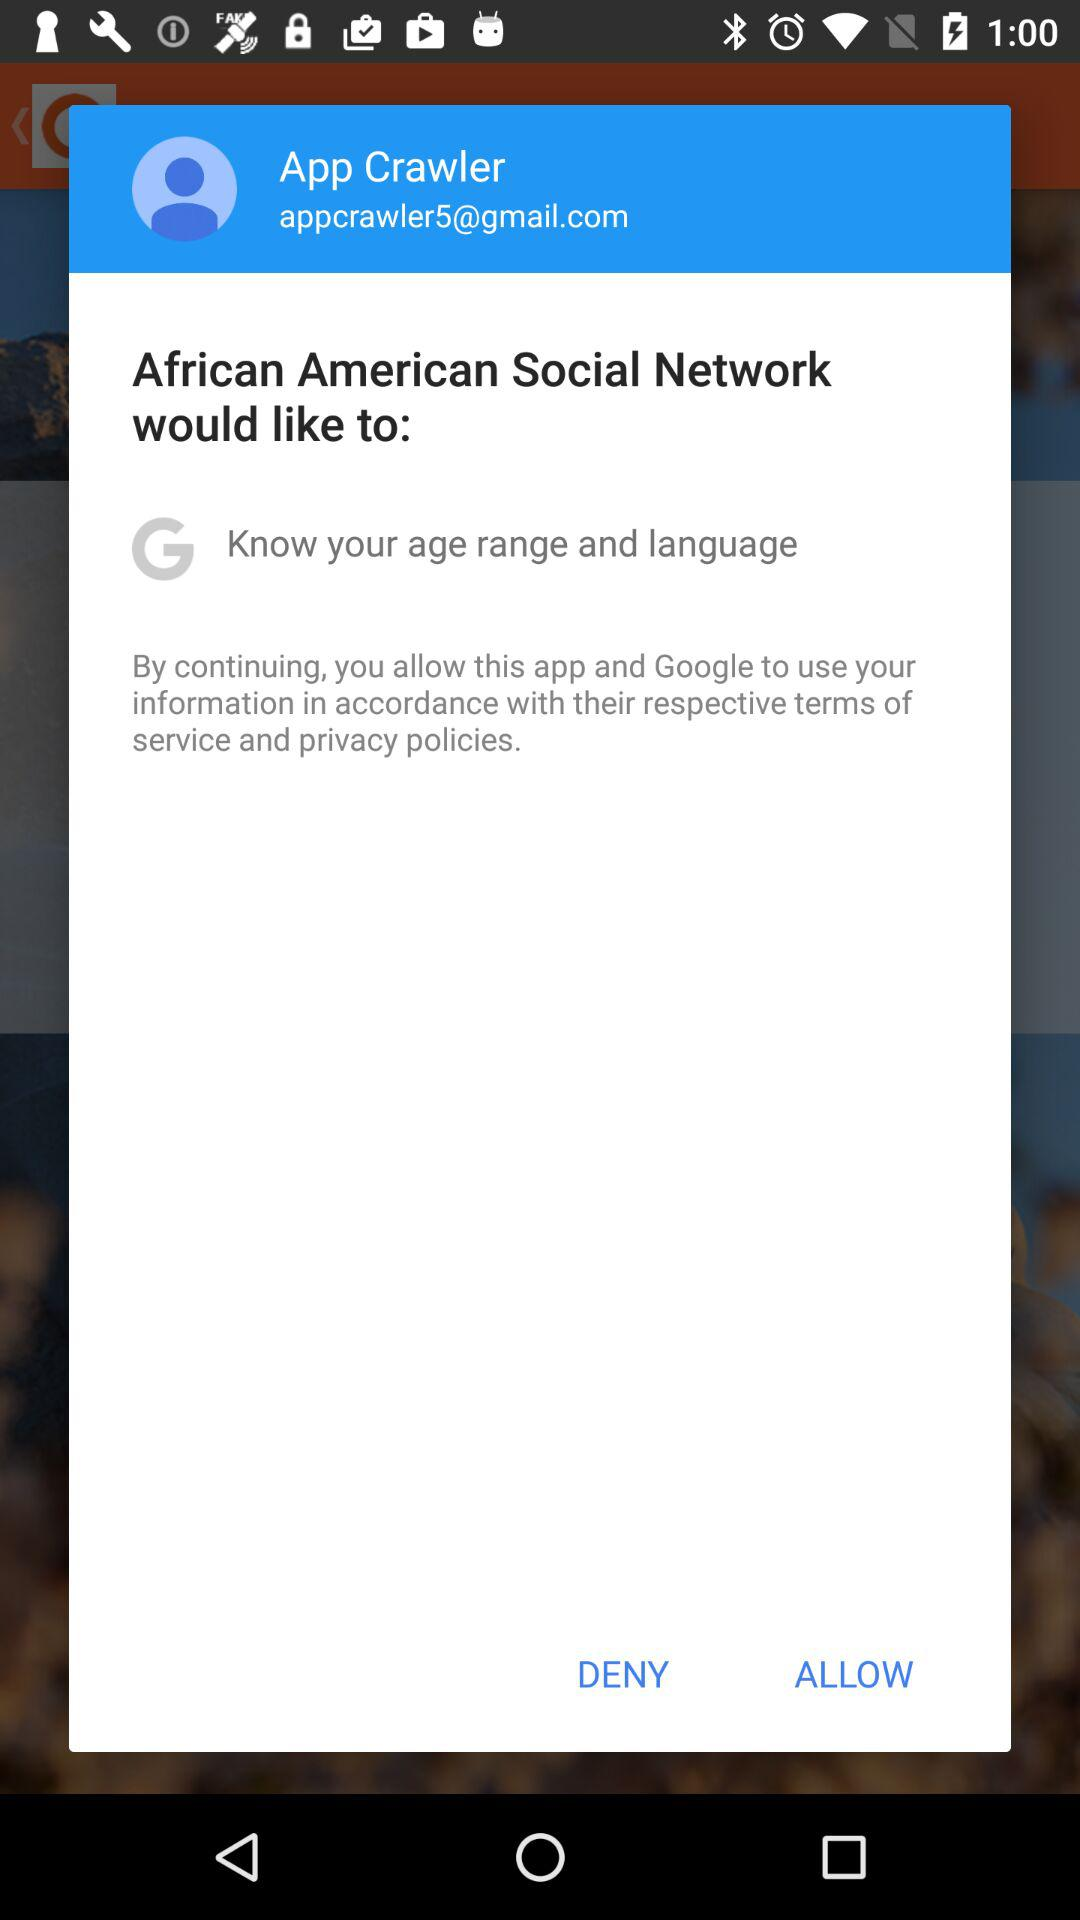What is the email address of the user? The email address of the user is appcrawler5@gmail.com. 